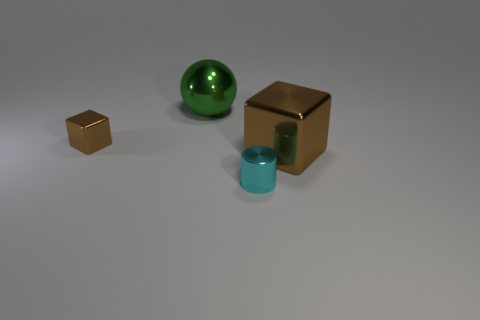Add 2 blue cubes. How many objects exist? 6 Subtract all spheres. How many objects are left? 3 Add 1 tiny brown cylinders. How many tiny brown cylinders exist? 1 Subtract 0 gray balls. How many objects are left? 4 Subtract all big brown things. Subtract all brown metal blocks. How many objects are left? 1 Add 4 big green things. How many big green things are left? 5 